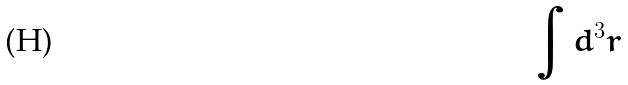<formula> <loc_0><loc_0><loc_500><loc_500>\int d ^ { 3 } r</formula> 